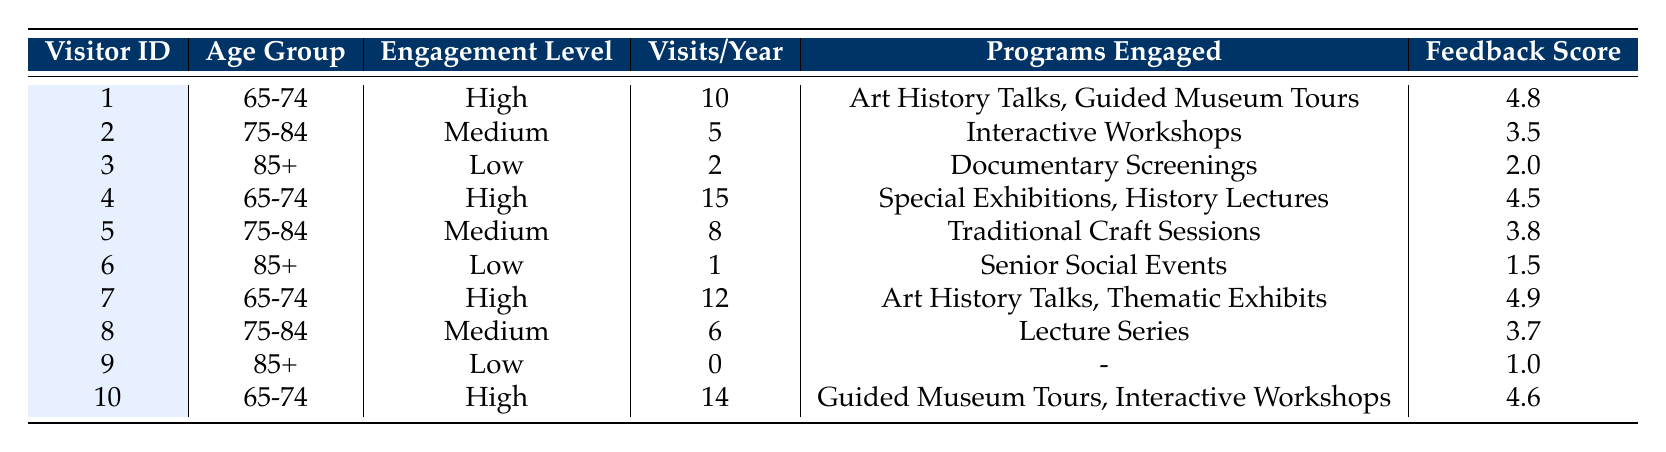What is the engagement level of visitor ID 3? Looking at the table, visitor ID 3 belongs to the age group "85+" and is listed with an engagement level of "Low."
Answer: Low How many total visits did the 65-74 age group make in a year? For the age group 65-74, I will add the visits per year: 10 (visitor 1) + 15 (visitor 4) + 12 (visitor 7) + 14 (visitor 10) = 51.
Answer: 51 Did any visitors in the age group 85+ have a high engagement level? Looking at the entries for age group 85+, visitor IDs 3, 6, and 9 all show "Low" engagement levels, which means no visitors in this age group have "High" engagement.
Answer: No What is the average feedback score for visitors aged 75-84? For this age group, the feedback scores are 3.5 (visitor 2), 3.8 (visitor 5), and 3.7 (visitor 8). The sum is 3.5 + 3.8 + 3.7 = 11. The average is 11 / 3 = approximately 3.67.
Answer: 3.67 How many unique programs were engaged by visitors in the age group 65-74? Visitors aged 65-74 are IDs 1, 4, 7, and 10. They engaged in: "Art History Talks," "Guided Museum Tours," "Special Exhibitions," "History Lectures," and "Thematic Exhibits." Counting all unique programs gives us five unique programs.
Answer: 5 What is the highest feedback score recorded among visitors? The highest feedback score among all visitors listed in the table is 4.9 from visitor ID 7 in the age group 65-74.
Answer: 4.9 Is there any visitor who did not engage in any programs? Reviewing the data, visitor ID 9 in the age group 85+ engaged in zero programs, indicating they did not engage in any activities.
Answer: Yes What is the difference in visits per year between the highest and lowest engagement levels? The highest engagement level (High) corresponds to visitor IDs 1, 4, 7, and 10. The maximum visits in this category are 15 (visitor 4). The lowest engagement level (Low) corresponds to visitor IDs 3, 6, and 9, with a maximum of 2 visits (visitor 3). Therefore, the difference is 15 - 2 = 13.
Answer: 13 Which age group has the most visitors engaged at a medium level? The medium engagement level corresponds to visitor IDs 2, 5, and 8, all of whom are in the age group 75-84. There are a total of three visitors in this category.
Answer: 75-84 